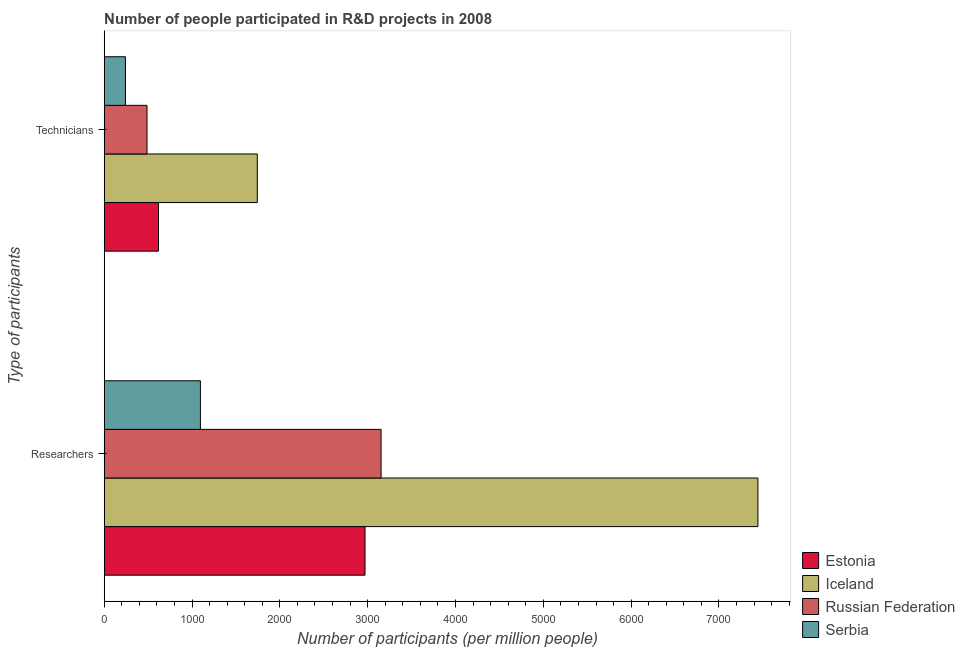Are the number of bars per tick equal to the number of legend labels?
Your response must be concise. Yes. How many bars are there on the 2nd tick from the top?
Offer a terse response. 4. How many bars are there on the 2nd tick from the bottom?
Give a very brief answer. 4. What is the label of the 2nd group of bars from the top?
Keep it short and to the point. Researchers. What is the number of researchers in Russian Federation?
Make the answer very short. 3152.62. Across all countries, what is the maximum number of technicians?
Provide a succinct answer. 1742.94. Across all countries, what is the minimum number of technicians?
Ensure brevity in your answer.  241.58. In which country was the number of technicians minimum?
Provide a succinct answer. Serbia. What is the total number of researchers in the graph?
Provide a succinct answer. 1.47e+04. What is the difference between the number of researchers in Estonia and that in Russian Federation?
Make the answer very short. -183.09. What is the difference between the number of technicians in Russian Federation and the number of researchers in Iceland?
Your answer should be very brief. -6956.01. What is the average number of technicians per country?
Keep it short and to the point. 772.44. What is the difference between the number of researchers and number of technicians in Iceland?
Make the answer very short. 5700.37. What is the ratio of the number of researchers in Estonia to that in Russian Federation?
Your response must be concise. 0.94. Is the number of researchers in Serbia less than that in Iceland?
Your answer should be compact. Yes. What does the 1st bar from the top in Technicians represents?
Give a very brief answer. Serbia. What does the 4th bar from the bottom in Researchers represents?
Your response must be concise. Serbia. Are all the bars in the graph horizontal?
Provide a short and direct response. Yes. How many countries are there in the graph?
Offer a terse response. 4. What is the difference between two consecutive major ticks on the X-axis?
Make the answer very short. 1000. Are the values on the major ticks of X-axis written in scientific E-notation?
Your response must be concise. No. What is the title of the graph?
Give a very brief answer. Number of people participated in R&D projects in 2008. What is the label or title of the X-axis?
Offer a terse response. Number of participants (per million people). What is the label or title of the Y-axis?
Your answer should be compact. Type of participants. What is the Number of participants (per million people) of Estonia in Researchers?
Provide a short and direct response. 2969.53. What is the Number of participants (per million people) in Iceland in Researchers?
Your response must be concise. 7443.32. What is the Number of participants (per million people) in Russian Federation in Researchers?
Provide a succinct answer. 3152.62. What is the Number of participants (per million people) of Serbia in Researchers?
Keep it short and to the point. 1095.36. What is the Number of participants (per million people) in Estonia in Technicians?
Offer a very short reply. 617.94. What is the Number of participants (per million people) of Iceland in Technicians?
Your answer should be very brief. 1742.94. What is the Number of participants (per million people) of Russian Federation in Technicians?
Offer a terse response. 487.31. What is the Number of participants (per million people) of Serbia in Technicians?
Ensure brevity in your answer.  241.58. Across all Type of participants, what is the maximum Number of participants (per million people) of Estonia?
Keep it short and to the point. 2969.53. Across all Type of participants, what is the maximum Number of participants (per million people) in Iceland?
Offer a terse response. 7443.32. Across all Type of participants, what is the maximum Number of participants (per million people) in Russian Federation?
Offer a terse response. 3152.62. Across all Type of participants, what is the maximum Number of participants (per million people) in Serbia?
Keep it short and to the point. 1095.36. Across all Type of participants, what is the minimum Number of participants (per million people) of Estonia?
Offer a very short reply. 617.94. Across all Type of participants, what is the minimum Number of participants (per million people) of Iceland?
Ensure brevity in your answer.  1742.94. Across all Type of participants, what is the minimum Number of participants (per million people) of Russian Federation?
Provide a succinct answer. 487.31. Across all Type of participants, what is the minimum Number of participants (per million people) of Serbia?
Offer a terse response. 241.58. What is the total Number of participants (per million people) of Estonia in the graph?
Keep it short and to the point. 3587.47. What is the total Number of participants (per million people) of Iceland in the graph?
Your answer should be compact. 9186.26. What is the total Number of participants (per million people) in Russian Federation in the graph?
Offer a very short reply. 3639.93. What is the total Number of participants (per million people) of Serbia in the graph?
Offer a terse response. 1336.94. What is the difference between the Number of participants (per million people) in Estonia in Researchers and that in Technicians?
Give a very brief answer. 2351.6. What is the difference between the Number of participants (per million people) of Iceland in Researchers and that in Technicians?
Keep it short and to the point. 5700.37. What is the difference between the Number of participants (per million people) of Russian Federation in Researchers and that in Technicians?
Provide a succinct answer. 2665.31. What is the difference between the Number of participants (per million people) in Serbia in Researchers and that in Technicians?
Give a very brief answer. 853.78. What is the difference between the Number of participants (per million people) of Estonia in Researchers and the Number of participants (per million people) of Iceland in Technicians?
Provide a short and direct response. 1226.59. What is the difference between the Number of participants (per million people) in Estonia in Researchers and the Number of participants (per million people) in Russian Federation in Technicians?
Keep it short and to the point. 2482.23. What is the difference between the Number of participants (per million people) of Estonia in Researchers and the Number of participants (per million people) of Serbia in Technicians?
Offer a terse response. 2727.95. What is the difference between the Number of participants (per million people) in Iceland in Researchers and the Number of participants (per million people) in Russian Federation in Technicians?
Offer a terse response. 6956.01. What is the difference between the Number of participants (per million people) in Iceland in Researchers and the Number of participants (per million people) in Serbia in Technicians?
Offer a very short reply. 7201.74. What is the difference between the Number of participants (per million people) of Russian Federation in Researchers and the Number of participants (per million people) of Serbia in Technicians?
Your answer should be very brief. 2911.04. What is the average Number of participants (per million people) of Estonia per Type of participants?
Your answer should be compact. 1793.74. What is the average Number of participants (per million people) of Iceland per Type of participants?
Your response must be concise. 4593.13. What is the average Number of participants (per million people) in Russian Federation per Type of participants?
Your answer should be very brief. 1819.96. What is the average Number of participants (per million people) in Serbia per Type of participants?
Provide a short and direct response. 668.47. What is the difference between the Number of participants (per million people) in Estonia and Number of participants (per million people) in Iceland in Researchers?
Your response must be concise. -4473.78. What is the difference between the Number of participants (per million people) in Estonia and Number of participants (per million people) in Russian Federation in Researchers?
Your response must be concise. -183.09. What is the difference between the Number of participants (per million people) of Estonia and Number of participants (per million people) of Serbia in Researchers?
Provide a short and direct response. 1874.18. What is the difference between the Number of participants (per million people) of Iceland and Number of participants (per million people) of Russian Federation in Researchers?
Give a very brief answer. 4290.7. What is the difference between the Number of participants (per million people) of Iceland and Number of participants (per million people) of Serbia in Researchers?
Your response must be concise. 6347.96. What is the difference between the Number of participants (per million people) in Russian Federation and Number of participants (per million people) in Serbia in Researchers?
Offer a very short reply. 2057.26. What is the difference between the Number of participants (per million people) in Estonia and Number of participants (per million people) in Iceland in Technicians?
Your answer should be very brief. -1125.01. What is the difference between the Number of participants (per million people) of Estonia and Number of participants (per million people) of Russian Federation in Technicians?
Your answer should be compact. 130.63. What is the difference between the Number of participants (per million people) in Estonia and Number of participants (per million people) in Serbia in Technicians?
Offer a terse response. 376.36. What is the difference between the Number of participants (per million people) of Iceland and Number of participants (per million people) of Russian Federation in Technicians?
Your response must be concise. 1255.64. What is the difference between the Number of participants (per million people) in Iceland and Number of participants (per million people) in Serbia in Technicians?
Your response must be concise. 1501.36. What is the difference between the Number of participants (per million people) in Russian Federation and Number of participants (per million people) in Serbia in Technicians?
Offer a terse response. 245.73. What is the ratio of the Number of participants (per million people) of Estonia in Researchers to that in Technicians?
Your answer should be very brief. 4.81. What is the ratio of the Number of participants (per million people) of Iceland in Researchers to that in Technicians?
Your answer should be very brief. 4.27. What is the ratio of the Number of participants (per million people) of Russian Federation in Researchers to that in Technicians?
Make the answer very short. 6.47. What is the ratio of the Number of participants (per million people) of Serbia in Researchers to that in Technicians?
Provide a succinct answer. 4.53. What is the difference between the highest and the second highest Number of participants (per million people) in Estonia?
Offer a very short reply. 2351.6. What is the difference between the highest and the second highest Number of participants (per million people) of Iceland?
Your answer should be very brief. 5700.37. What is the difference between the highest and the second highest Number of participants (per million people) of Russian Federation?
Offer a very short reply. 2665.31. What is the difference between the highest and the second highest Number of participants (per million people) in Serbia?
Your response must be concise. 853.78. What is the difference between the highest and the lowest Number of participants (per million people) of Estonia?
Offer a terse response. 2351.6. What is the difference between the highest and the lowest Number of participants (per million people) in Iceland?
Your answer should be compact. 5700.37. What is the difference between the highest and the lowest Number of participants (per million people) in Russian Federation?
Make the answer very short. 2665.31. What is the difference between the highest and the lowest Number of participants (per million people) in Serbia?
Provide a short and direct response. 853.78. 